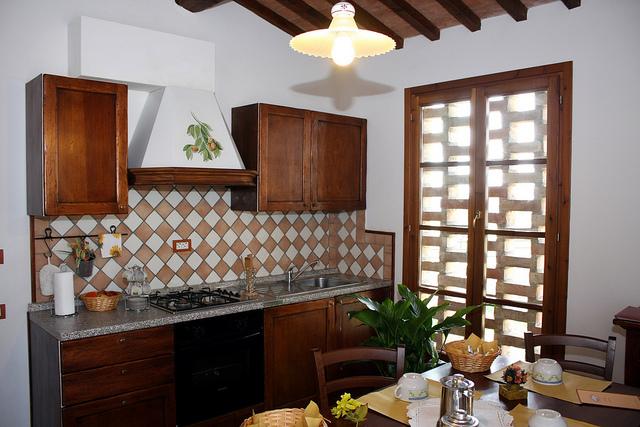Is there a desk in this room?
Concise answer only. No. How many lamps are in this room?
Short answer required. 1. Is the light on?
Answer briefly. Yes. What color are the tiles on the wall?
Concise answer only. Brown. What kind of room is this?
Write a very short answer. Kitchen. What pattern is on the backsplash?
Give a very brief answer. Diamonds. What type of cups are on the table?
Give a very brief answer. Coffee cups. 